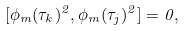Convert formula to latex. <formula><loc_0><loc_0><loc_500><loc_500>[ \phi _ { m } ( \tau _ { k } ) ^ { 2 } , \phi _ { m } ( \tau _ { j } ) ^ { 2 } ] = 0 ,</formula> 